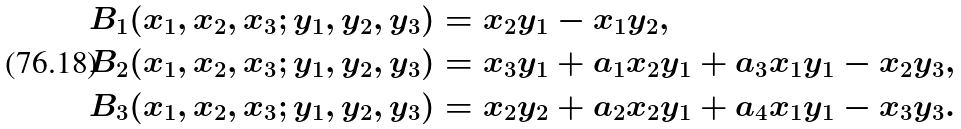Convert formula to latex. <formula><loc_0><loc_0><loc_500><loc_500>B _ { 1 } ( x _ { 1 } , x _ { 2 } , x _ { 3 } ; y _ { 1 } , y _ { 2 } , y _ { 3 } ) & = x _ { 2 } y _ { 1 } - x _ { 1 } y _ { 2 } , \\ B _ { 2 } ( x _ { 1 } , x _ { 2 } , x _ { 3 } ; y _ { 1 } , y _ { 2 } , y _ { 3 } ) & = x _ { 3 } y _ { 1 } + a _ { 1 } x _ { 2 } y _ { 1 } + a _ { 3 } x _ { 1 } y _ { 1 } - x _ { 2 } y _ { 3 } , \\ B _ { 3 } ( x _ { 1 } , x _ { 2 } , x _ { 3 } ; y _ { 1 } , y _ { 2 } , y _ { 3 } ) & = x _ { 2 } y _ { 2 } + a _ { 2 } x _ { 2 } y _ { 1 } + a _ { 4 } x _ { 1 } y _ { 1 } - x _ { 3 } y _ { 3 } .</formula> 